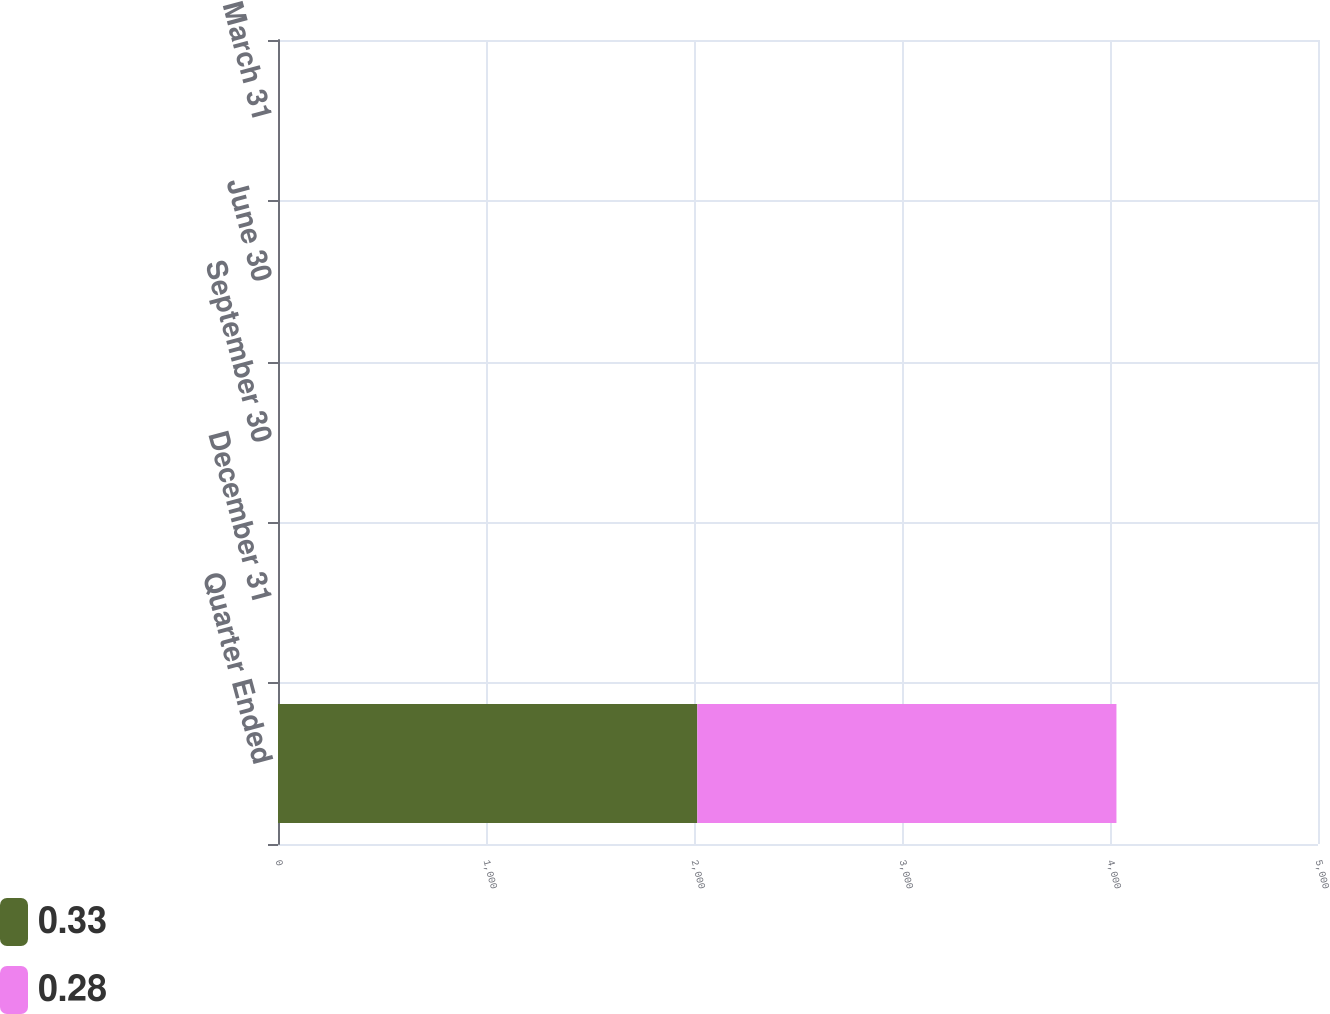Convert chart to OTSL. <chart><loc_0><loc_0><loc_500><loc_500><stacked_bar_chart><ecel><fcel>Quarter Ended<fcel>December 31<fcel>September 30<fcel>June 30<fcel>March 31<nl><fcel>0.33<fcel>2016<fcel>0.33<fcel>0.33<fcel>0.33<fcel>0.33<nl><fcel>0.28<fcel>2015<fcel>0.3<fcel>0.3<fcel>0.3<fcel>0.28<nl></chart> 